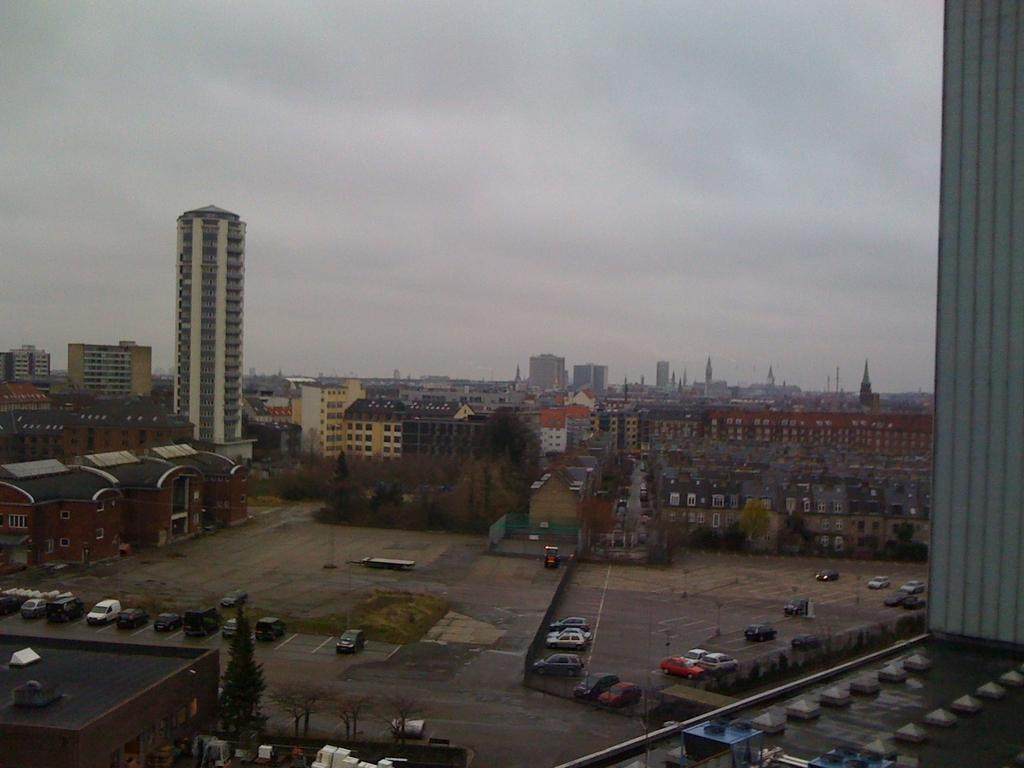What type of location is depicted in the image? The image is of a city. What can be seen in the foreground of the picture? There are buildings, cars, and trees in the foreground of the picture. What is present in the center of the picture? There are buildings, trees, and roads in the center of the picture. What is the condition of the sky in the image? The sky is cloudy in the image. What type of nail is being used to control the traffic in the image? There is no nail present in the image, nor is there any indication of traffic control. 